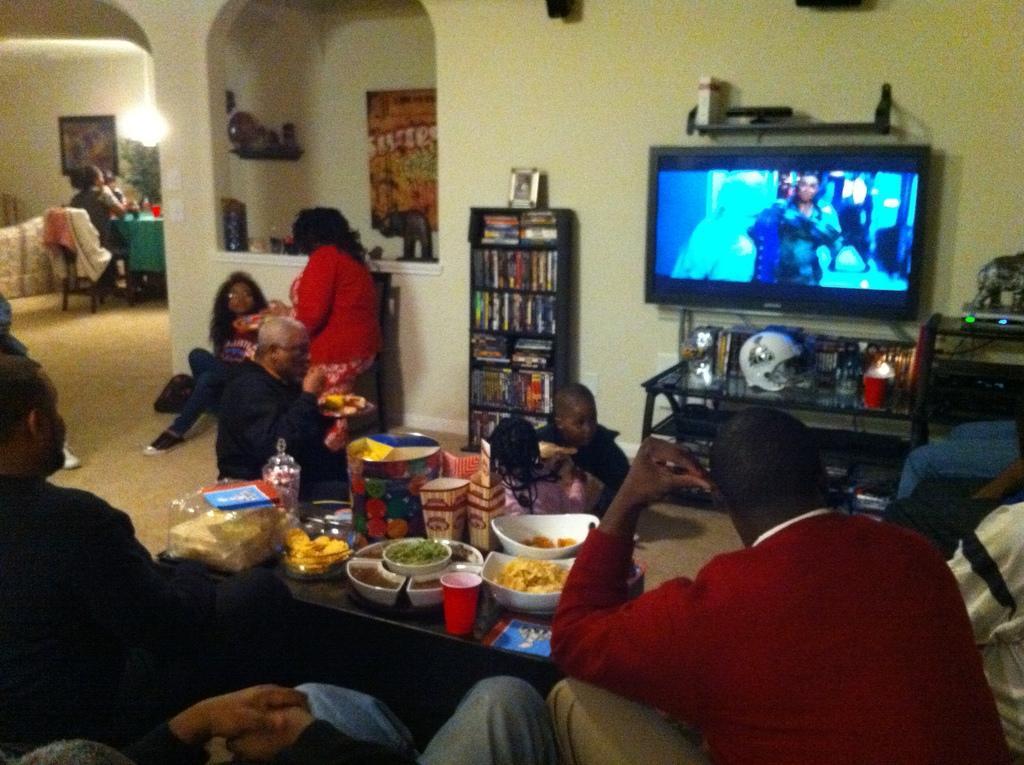In one or two sentences, can you explain what this image depicts? this picture shows few people seated on the chairs and we see a television and a bookshelf and few food with bowls and glasses on the table 